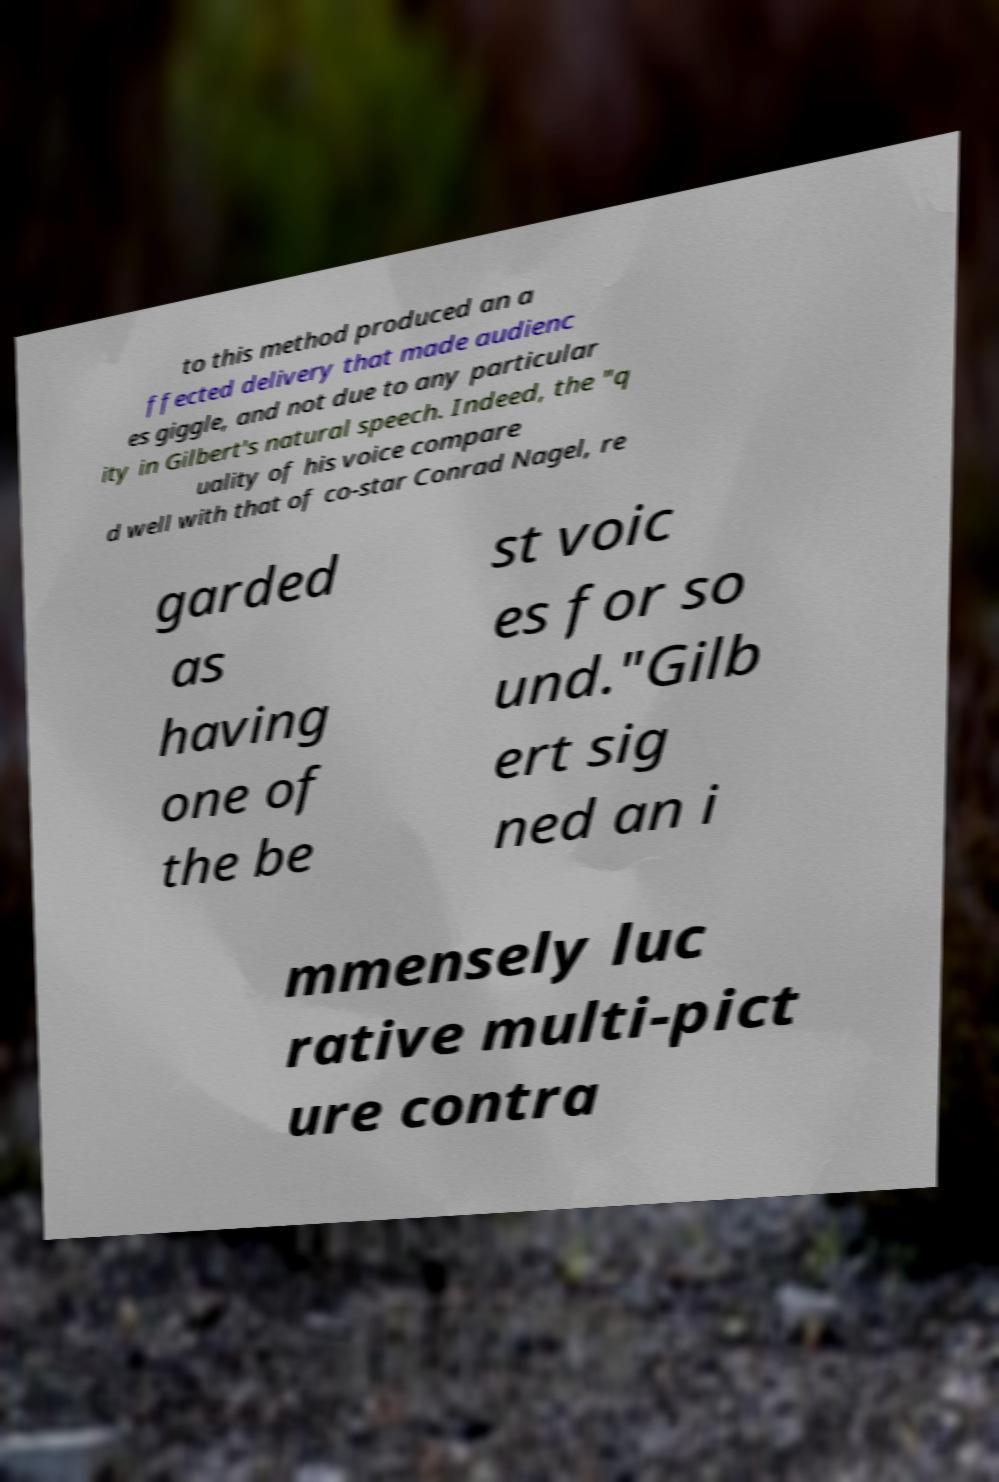For documentation purposes, I need the text within this image transcribed. Could you provide that? to this method produced an a ffected delivery that made audienc es giggle, and not due to any particular ity in Gilbert's natural speech. Indeed, the "q uality of his voice compare d well with that of co-star Conrad Nagel, re garded as having one of the be st voic es for so und."Gilb ert sig ned an i mmensely luc rative multi-pict ure contra 